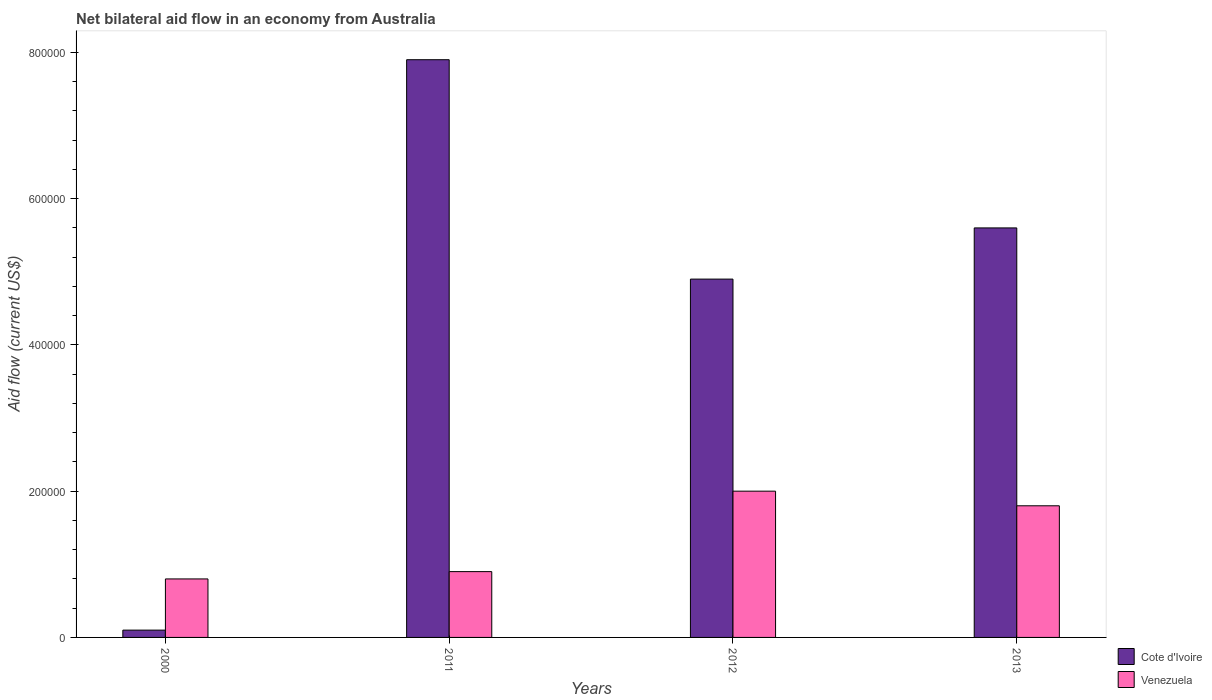How many different coloured bars are there?
Your answer should be very brief. 2. How many groups of bars are there?
Your answer should be compact. 4. Are the number of bars per tick equal to the number of legend labels?
Give a very brief answer. Yes. How many bars are there on the 2nd tick from the right?
Offer a terse response. 2. In how many cases, is the number of bars for a given year not equal to the number of legend labels?
Offer a very short reply. 0. What is the net bilateral aid flow in Cote d'Ivoire in 2011?
Your answer should be very brief. 7.90e+05. Across all years, what is the maximum net bilateral aid flow in Cote d'Ivoire?
Make the answer very short. 7.90e+05. In which year was the net bilateral aid flow in Cote d'Ivoire maximum?
Keep it short and to the point. 2011. In which year was the net bilateral aid flow in Cote d'Ivoire minimum?
Your answer should be compact. 2000. What is the total net bilateral aid flow in Cote d'Ivoire in the graph?
Your answer should be compact. 1.85e+06. What is the difference between the net bilateral aid flow in Cote d'Ivoire in 2000 and the net bilateral aid flow in Venezuela in 2012?
Make the answer very short. -1.90e+05. What is the average net bilateral aid flow in Cote d'Ivoire per year?
Your response must be concise. 4.62e+05. In the year 2012, what is the difference between the net bilateral aid flow in Venezuela and net bilateral aid flow in Cote d'Ivoire?
Your answer should be very brief. -2.90e+05. In how many years, is the net bilateral aid flow in Venezuela greater than 320000 US$?
Make the answer very short. 0. What is the ratio of the net bilateral aid flow in Venezuela in 2011 to that in 2012?
Your answer should be compact. 0.45. What is the difference between the highest and the lowest net bilateral aid flow in Cote d'Ivoire?
Make the answer very short. 7.80e+05. Is the sum of the net bilateral aid flow in Venezuela in 2000 and 2013 greater than the maximum net bilateral aid flow in Cote d'Ivoire across all years?
Keep it short and to the point. No. What does the 2nd bar from the left in 2012 represents?
Give a very brief answer. Venezuela. What does the 1st bar from the right in 2013 represents?
Offer a terse response. Venezuela. How many bars are there?
Offer a very short reply. 8. Are all the bars in the graph horizontal?
Make the answer very short. No. How many years are there in the graph?
Offer a very short reply. 4. Are the values on the major ticks of Y-axis written in scientific E-notation?
Provide a succinct answer. No. What is the title of the graph?
Your answer should be very brief. Net bilateral aid flow in an economy from Australia. What is the label or title of the X-axis?
Keep it short and to the point. Years. What is the Aid flow (current US$) in Cote d'Ivoire in 2011?
Offer a very short reply. 7.90e+05. What is the Aid flow (current US$) in Venezuela in 2011?
Give a very brief answer. 9.00e+04. What is the Aid flow (current US$) in Venezuela in 2012?
Provide a short and direct response. 2.00e+05. What is the Aid flow (current US$) in Cote d'Ivoire in 2013?
Give a very brief answer. 5.60e+05. Across all years, what is the maximum Aid flow (current US$) of Cote d'Ivoire?
Provide a succinct answer. 7.90e+05. Across all years, what is the minimum Aid flow (current US$) of Venezuela?
Offer a very short reply. 8.00e+04. What is the total Aid flow (current US$) in Cote d'Ivoire in the graph?
Make the answer very short. 1.85e+06. What is the difference between the Aid flow (current US$) in Cote d'Ivoire in 2000 and that in 2011?
Give a very brief answer. -7.80e+05. What is the difference between the Aid flow (current US$) of Venezuela in 2000 and that in 2011?
Give a very brief answer. -10000. What is the difference between the Aid flow (current US$) of Cote d'Ivoire in 2000 and that in 2012?
Ensure brevity in your answer.  -4.80e+05. What is the difference between the Aid flow (current US$) in Cote d'Ivoire in 2000 and that in 2013?
Provide a succinct answer. -5.50e+05. What is the difference between the Aid flow (current US$) of Venezuela in 2000 and that in 2013?
Give a very brief answer. -1.00e+05. What is the difference between the Aid flow (current US$) in Venezuela in 2011 and that in 2012?
Ensure brevity in your answer.  -1.10e+05. What is the difference between the Aid flow (current US$) in Cote d'Ivoire in 2011 and that in 2013?
Offer a terse response. 2.30e+05. What is the difference between the Aid flow (current US$) in Venezuela in 2012 and that in 2013?
Provide a succinct answer. 2.00e+04. What is the difference between the Aid flow (current US$) in Cote d'Ivoire in 2011 and the Aid flow (current US$) in Venezuela in 2012?
Your response must be concise. 5.90e+05. What is the difference between the Aid flow (current US$) in Cote d'Ivoire in 2011 and the Aid flow (current US$) in Venezuela in 2013?
Make the answer very short. 6.10e+05. What is the average Aid flow (current US$) of Cote d'Ivoire per year?
Your answer should be very brief. 4.62e+05. What is the average Aid flow (current US$) in Venezuela per year?
Offer a terse response. 1.38e+05. In the year 2011, what is the difference between the Aid flow (current US$) of Cote d'Ivoire and Aid flow (current US$) of Venezuela?
Provide a short and direct response. 7.00e+05. What is the ratio of the Aid flow (current US$) in Cote d'Ivoire in 2000 to that in 2011?
Provide a short and direct response. 0.01. What is the ratio of the Aid flow (current US$) of Cote d'Ivoire in 2000 to that in 2012?
Offer a very short reply. 0.02. What is the ratio of the Aid flow (current US$) in Venezuela in 2000 to that in 2012?
Provide a succinct answer. 0.4. What is the ratio of the Aid flow (current US$) of Cote d'Ivoire in 2000 to that in 2013?
Offer a terse response. 0.02. What is the ratio of the Aid flow (current US$) in Venezuela in 2000 to that in 2013?
Ensure brevity in your answer.  0.44. What is the ratio of the Aid flow (current US$) of Cote d'Ivoire in 2011 to that in 2012?
Keep it short and to the point. 1.61. What is the ratio of the Aid flow (current US$) of Venezuela in 2011 to that in 2012?
Offer a very short reply. 0.45. What is the ratio of the Aid flow (current US$) of Cote d'Ivoire in 2011 to that in 2013?
Make the answer very short. 1.41. What is the ratio of the Aid flow (current US$) in Venezuela in 2011 to that in 2013?
Your response must be concise. 0.5. What is the ratio of the Aid flow (current US$) of Venezuela in 2012 to that in 2013?
Keep it short and to the point. 1.11. What is the difference between the highest and the second highest Aid flow (current US$) of Venezuela?
Offer a terse response. 2.00e+04. What is the difference between the highest and the lowest Aid flow (current US$) in Cote d'Ivoire?
Provide a short and direct response. 7.80e+05. What is the difference between the highest and the lowest Aid flow (current US$) of Venezuela?
Keep it short and to the point. 1.20e+05. 